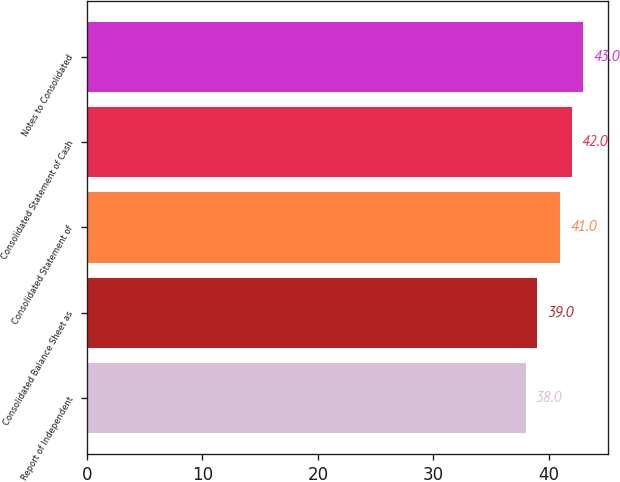<chart> <loc_0><loc_0><loc_500><loc_500><bar_chart><fcel>Report of Independent<fcel>Consolidated Balance Sheet as<fcel>Consolidated Statement of<fcel>Consolidated Statement of Cash<fcel>Notes to Consolidated<nl><fcel>38<fcel>39<fcel>41<fcel>42<fcel>43<nl></chart> 